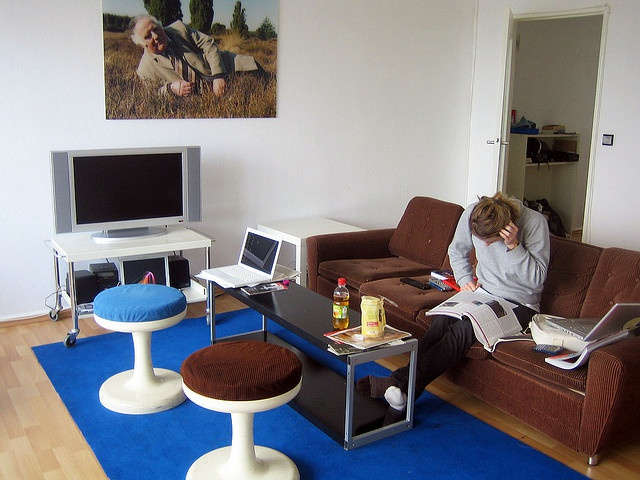Describe the objects in this image and their specific colors. I can see couch in lightgray, maroon, black, brown, and gray tones, tv in lightgray, black, darkgray, gray, and white tones, people in lightgray, black, darkgray, and gray tones, chair in lightgray, maroon, ivory, black, and darkgray tones, and chair in lightgray, maroon, black, and brown tones in this image. 